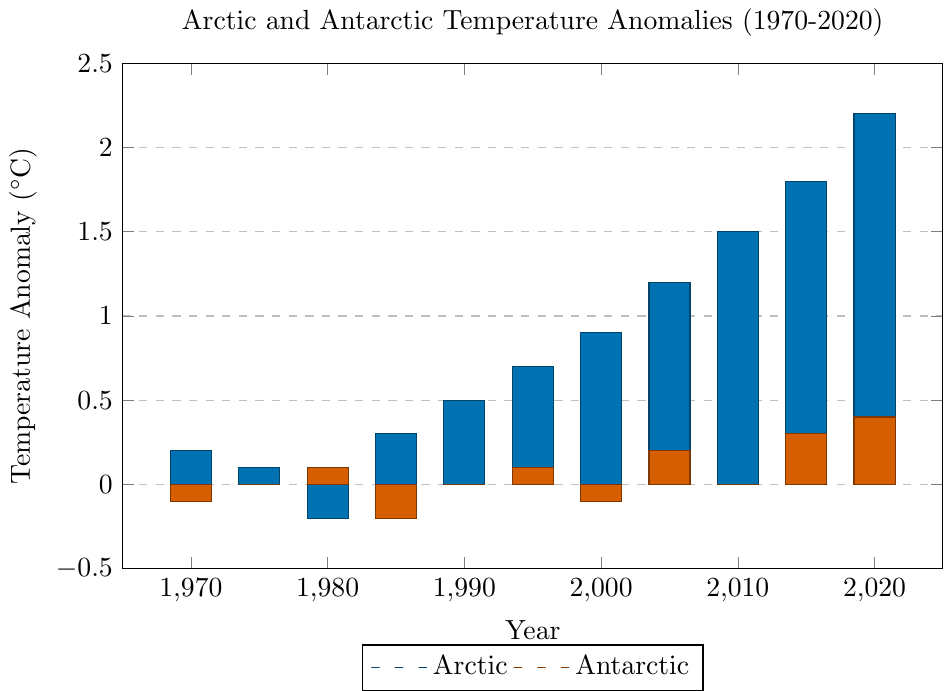What are the temperature anomalies for the Arctic in 1980 and 2020? The figure shows bars representing the Arctic temperature anomalies for each year. The bar for 1980 shows a value of -0.2°C and the bar for 2020 shows a value of 2.2°C.
Answer: -0.2°C and 2.2°C Which year has the highest temperature anomaly for the Arctic, and what is the value? By examining the heights of the Arctic bars, the highest bar corresponds to the year 2020 with a temperature anomaly of 2.2°C.
Answer: 2020, 2.2°C What is the difference in temperature anomaly between Arctic and Antarctic regions in 2005? The Arctic bar for 2005 shows a value of 1.2°C, and the Antarctic bar for the same year shows a value of 0.2°C. The difference is 1.2 - 0.2 = 1.0°C.
Answer: 1.0°C Compare the temperature anomalies for the Arctic and Antarctic regions in 1995. Which is greater, and by how much? The Arctic bar for 1995 has a value of 0.7°C, and the Antarctic bar has a value of 0.1°C. The Arctic anomaly is greater by 0.7 - 0.1 = 0.6°C.
Answer: Arctic by 0.6°C How have the Arctic temperature anomalies changed between 1970 and 2020? Between 1970 and 2020, the Arctic temperature anomaly has increased from 0.2°C to 2.2°C, indicating a rise of 2.2 - 0.2 = 2.0°C.
Answer: Increased by 2.0°C Which region experienced a negative temperature anomaly in 1985, and what was the value? By checking the bars for 1985, the Antarctic region shows a negative temperature anomaly of -0.2°C.
Answer: Antarctic, -0.2°C What is the average temperature anomaly for the Arctic region over the 50 years displayed? Sum the temperature anomalies for the Arctic (0.2, 0.1, -0.2, 0.3, 0.5, 0.7, 0.9, 1.2, 1.5, 1.8, 2.2), which equals 9.2°C. There are 11 years, so the average is 9.2 / 11 ≈ 0.836°C.
Answer: 0.836°C Are there any years when both the Arctic and Antarctic regions have the same temperature anomaly? If so, in which years? By comparing the bars for both regions across all years, both regions have the same temperature anomaly of 0.0°C in 1975, 1990, and 2010.
Answer: 1975, 1990, 2010 How much did the Antarctic temperature anomaly change from 1980 to 2015? The Antarctic temperature anomaly is 0.1°C in 1980 and 0.3°C in 2015. The change is 0.3 - 0.1 = 0.2°C.
Answer: Increased by 0.2°C What trend do you observe in the Arctic temperature anomalies from 1970 to 2020? Observing the sequence of the Arctic bars from 1970 to 2020, there is a noticeable upward trend, showing a consistent increase in temperature anomalies over the 50-year span.
Answer: Upward trend 